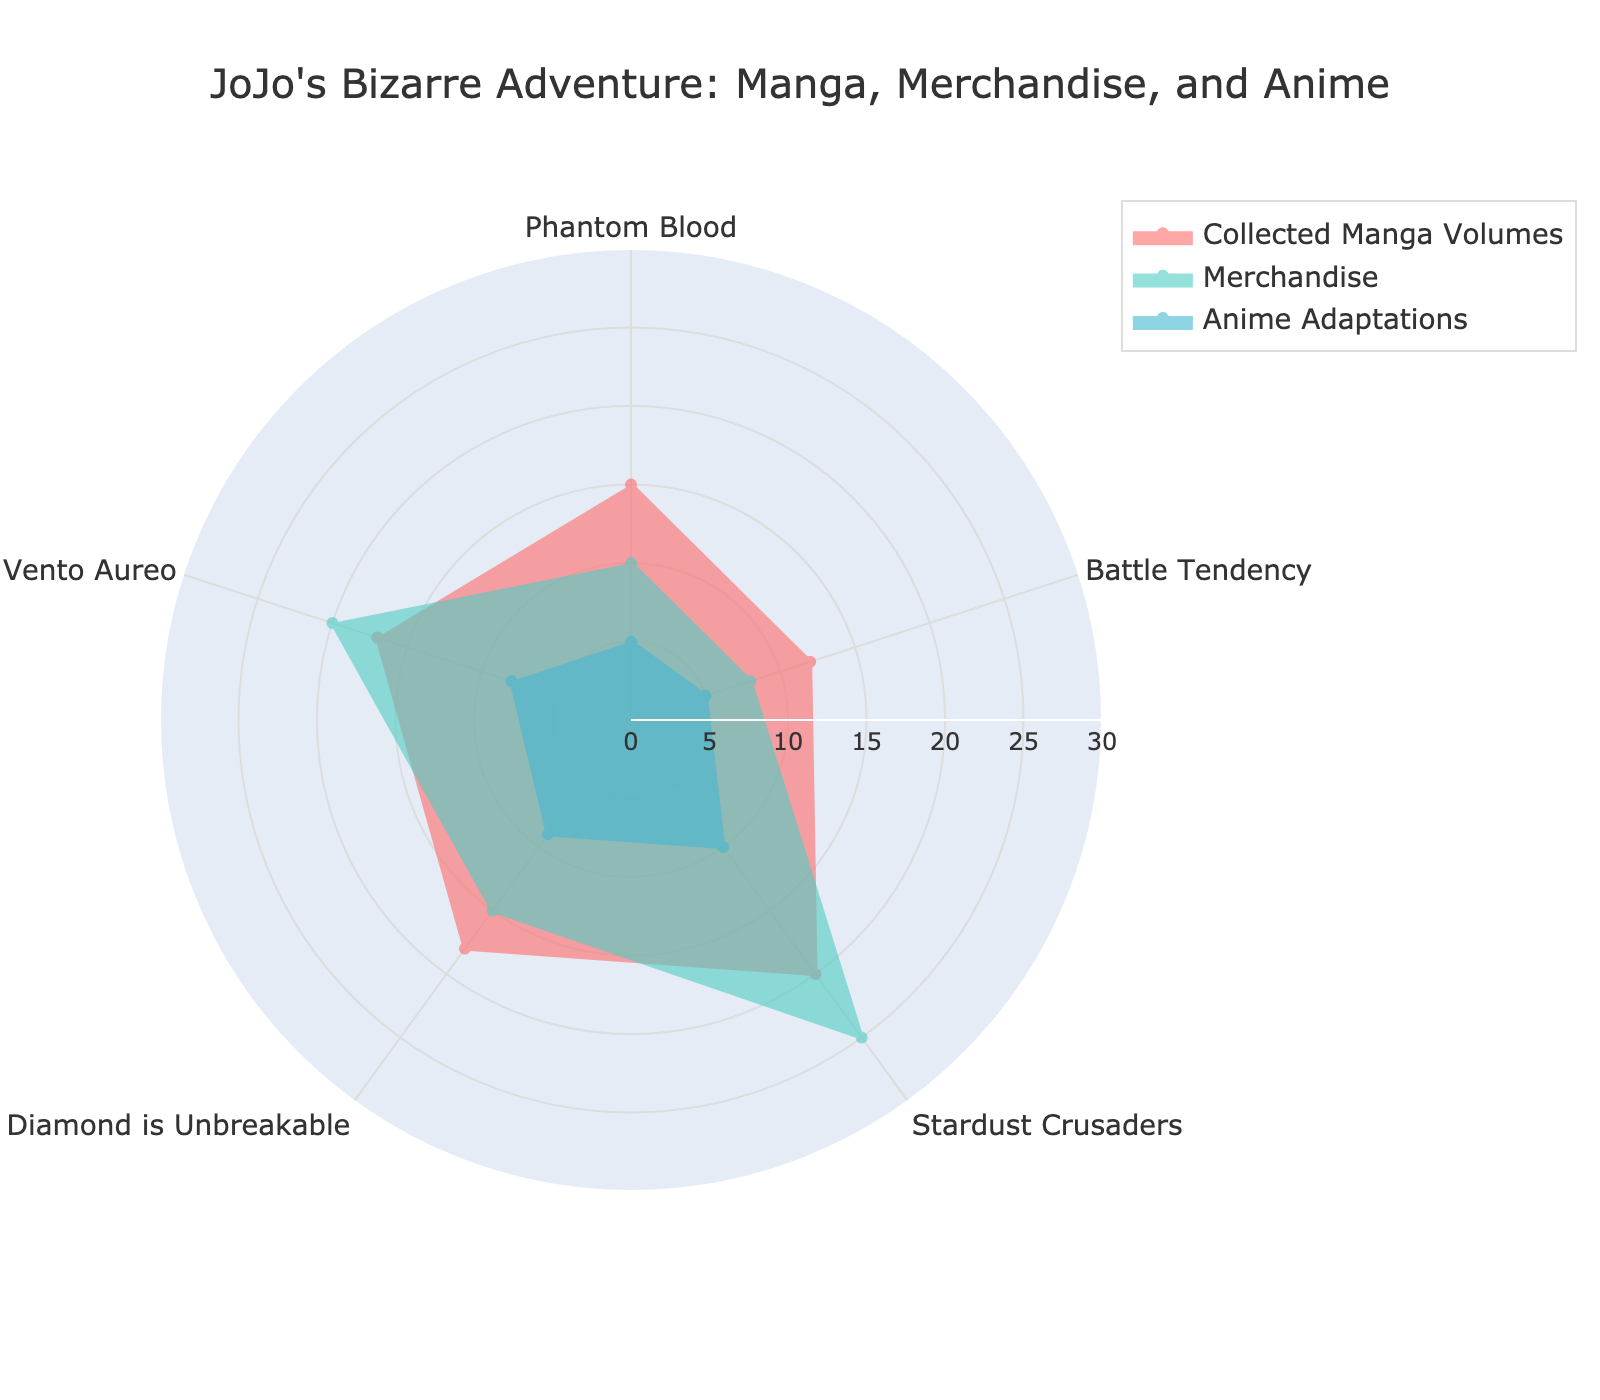What's the title of the figure? The title is typically prominently displayed at the top of the figure. Here, it clearly states "JoJo's Bizarre Adventure: Manga, Merchandise, and Anime".
Answer: JoJo's Bizarre Adventure: Manga, Merchandise, and Anime Which part has the highest value for collected manga volumes? By examining the radar chart, you can see that the line representing "Collected Manga Volumes" peaks at "Stardust Crusaders".
Answer: Stardust Crusaders What is the range of the radial axis? The radial axis range specifies the minimum and maximum values plotted on the chart. Based on the chart, it can be observed that the range is from 0 to 30.
Answer: 0 to 30 Which part shows the greatest difference between collected manga volumes and anime adaptations? To determine this, find the part where the difference between "Collected Manga Volumes" and "Anime Adaptations" is the greatest. For "Stardust Crusaders", it's 20 volumes vs 10 adaptations, a difference of 10. None of the other parts exhibit a larger difference.
Answer: Stardust Crusaders What's the average number of merchandise items across all parts? To find this, add up all the merchandise values for each part and divide by the number of parts. The total is 10 + 8 + 25 + 15 + 20 = 78. There are 5 parts, so the average is 78/5 = 15.6.
Answer: 15.6 Does "Diamond is Unbreakable" have more collected manga volumes or merchandise items? By comparing the two values on the chart for "Diamond is Unbreakable", you see that it has 18 collected manga volumes and 15 merchandise items.
Answer: Collected manga volumes Among the given parts, which has the lowest number of anime adaptations? By assessing each part's value for "Anime Adaptations", it is observable that "Phantom Blood" and "Battle Tendency" have the lowest, with 5 each.
Answer: Phantom Blood and Battle Tendency Which part has the most balanced distribution across all three categories? A balanced distribution would mean that the values for collected manga volumes, merchandise, and anime adaptations are relatively close. "Vento Aureo" has 17, 20, and 8, respectively, while other parts show more significant differences.
Answer: Vento Aureo How many more manga volumes are there for "Vento Aureo" than anime adaptations? Subtract the number of anime adaptations from the manga volumes for "Vento Aureo": 17 - 8 = 9.
Answer: 9 If you were to sum up all the collected manga volumes for the parts "Phantom Blood" and "Battle Tendency", what would be the total? Add the collected manga volumes for both parts: 15 (Phantom Blood) + 12 (Battle Tendency) = 27.
Answer: 27 